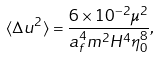Convert formula to latex. <formula><loc_0><loc_0><loc_500><loc_500>\langle \Delta u ^ { 2 } \rangle = \frac { 6 \times 1 0 ^ { - 2 } \mu ^ { 2 } } { a _ { f } ^ { 4 } m ^ { 2 } H ^ { 4 } \eta _ { 0 } ^ { 8 } } ,</formula> 